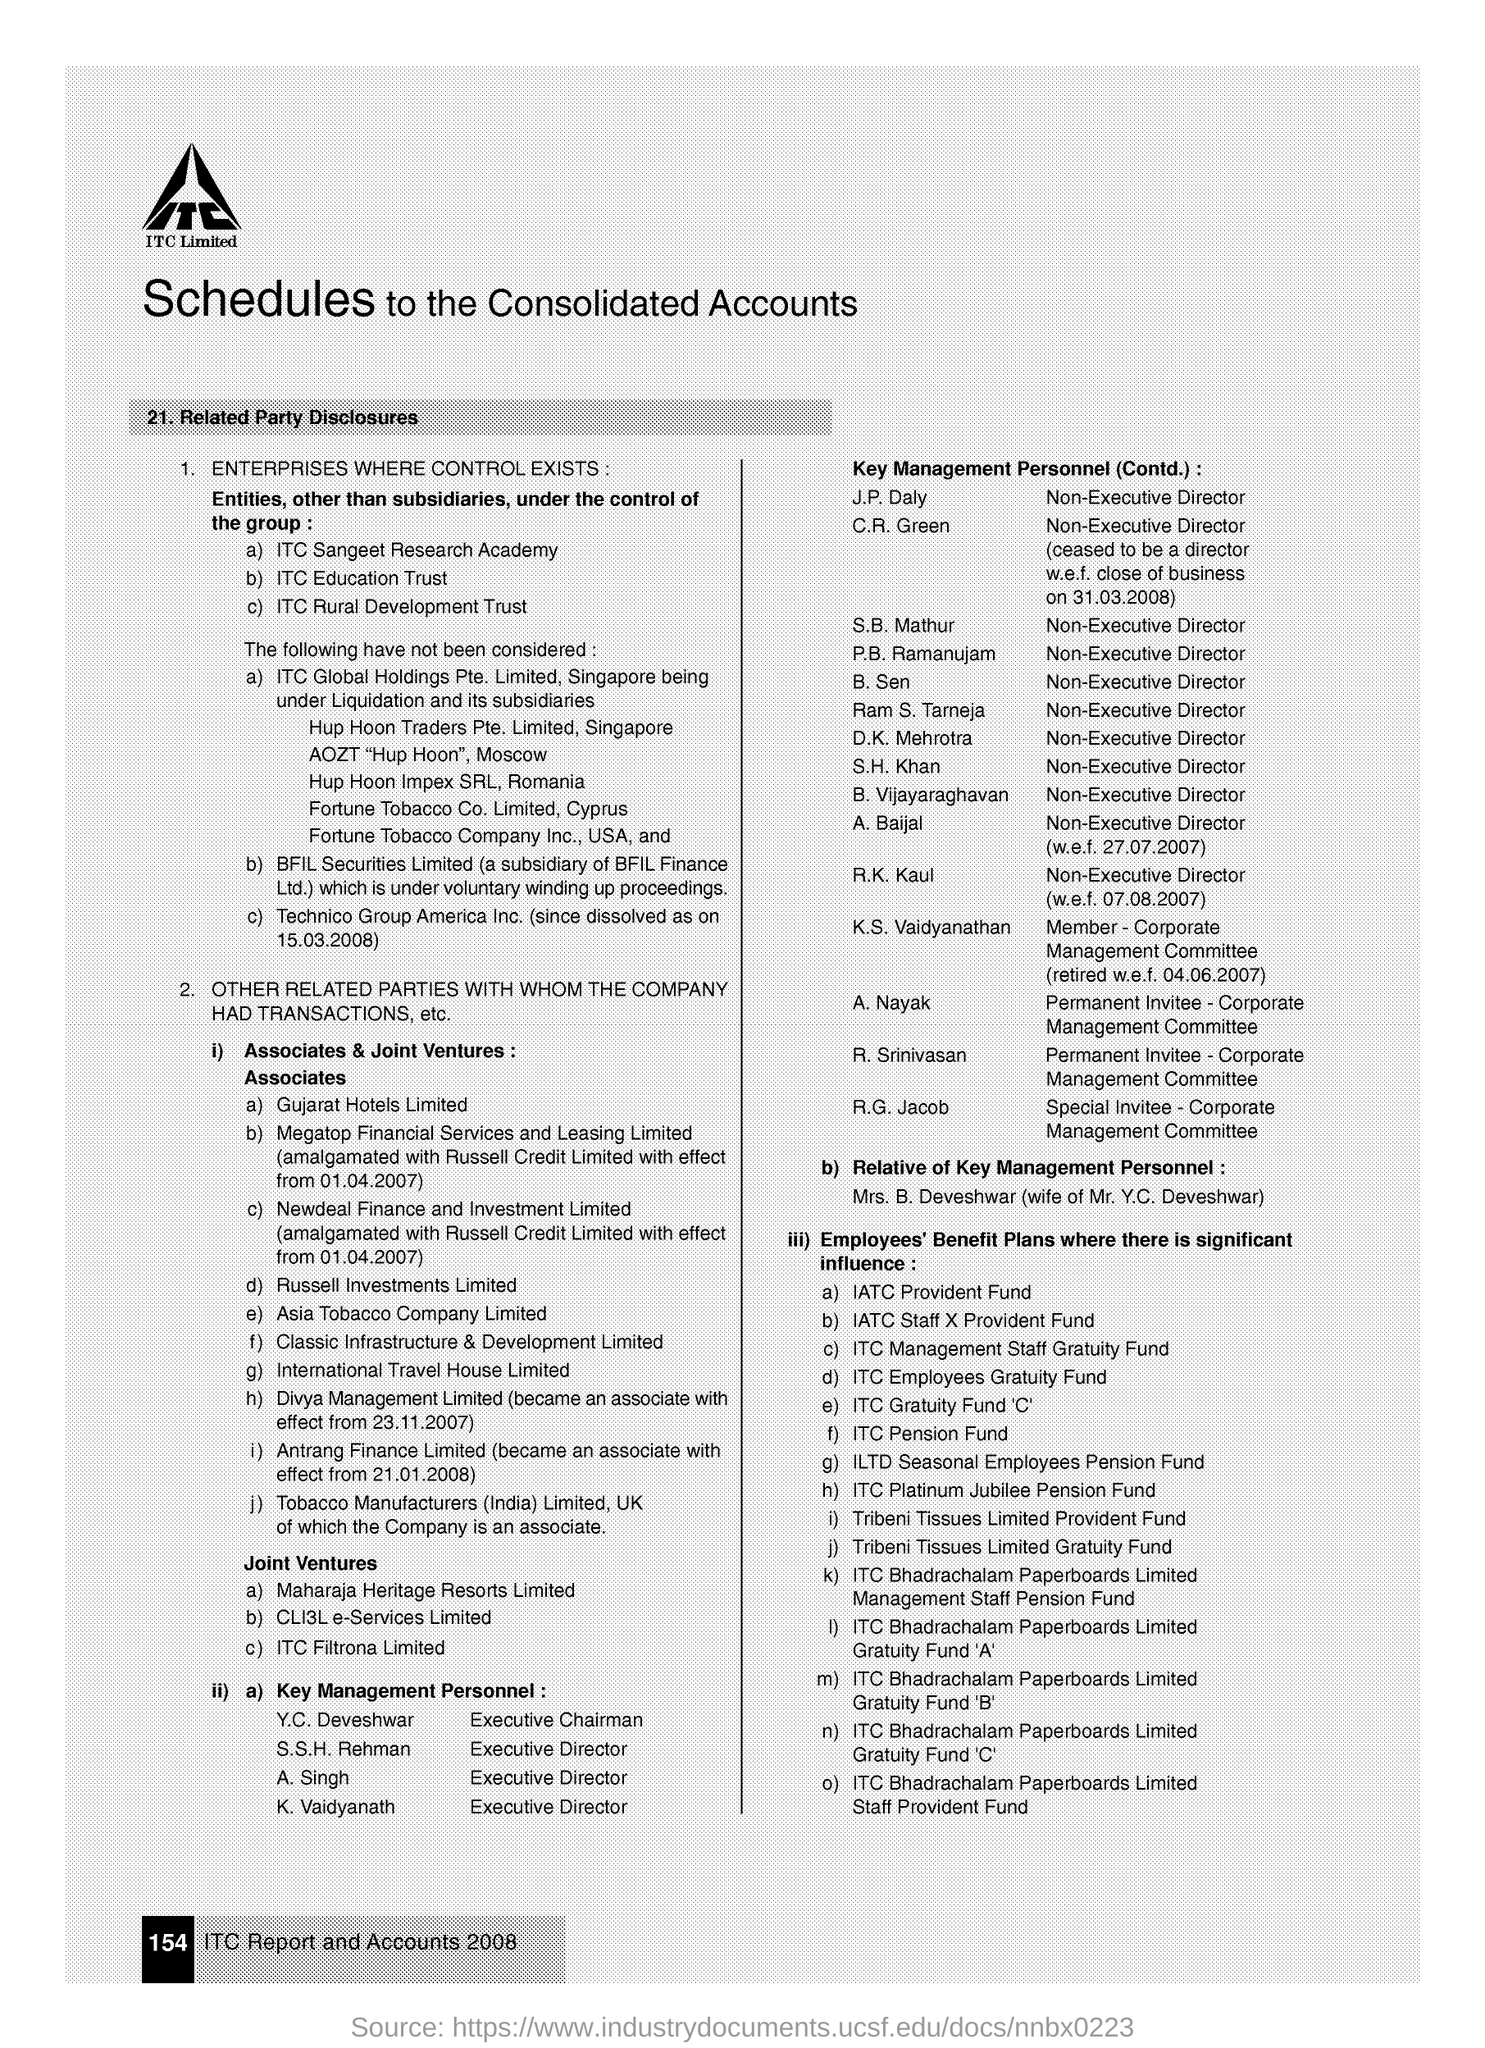Draw attention to some important aspects in this diagram. The main title of this document is 'Schedules to the Consolidated Accounts.' S.B. Mathur is a Non-Executive Director. The wife of Mr. Y.C. Deveshwar is Mrs. B. Deveshwar. The Corporate Management Committee is a special invitee. The document mentions page 154. 